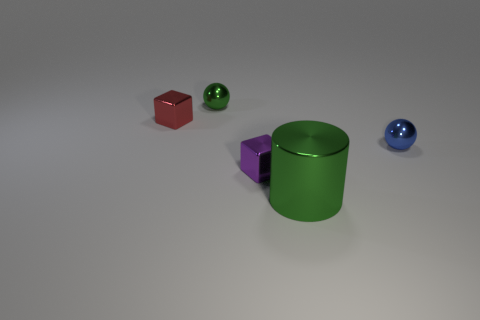What is the size of the cylinder?
Ensure brevity in your answer.  Large. How many metal things are brown cylinders or blue spheres?
Your answer should be compact. 1. Is the number of small blue metal things less than the number of tiny yellow rubber things?
Give a very brief answer. No. What number of other things are the same material as the cylinder?
Provide a succinct answer. 4. The other shiny thing that is the same shape as the tiny purple object is what size?
Offer a terse response. Small. Do the tiny object behind the red metal object and the small block right of the red block have the same material?
Your answer should be compact. Yes. Is the number of small blue balls that are on the left side of the green metallic cylinder less than the number of big brown things?
Make the answer very short. No. Is there anything else that has the same shape as the tiny purple object?
Provide a short and direct response. Yes. What is the color of the other object that is the same shape as the tiny green thing?
Your answer should be very brief. Blue. There is a green thing behind the red thing; does it have the same size as the large green shiny cylinder?
Your answer should be compact. No. 